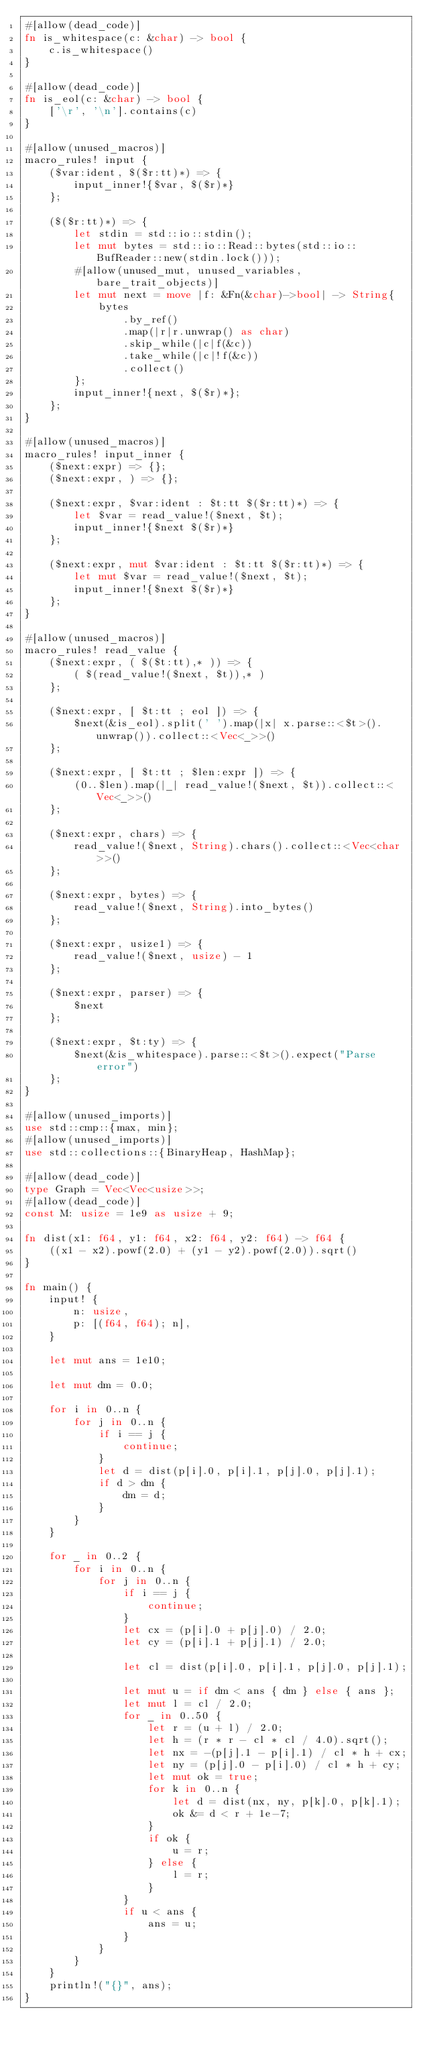Convert code to text. <code><loc_0><loc_0><loc_500><loc_500><_Rust_>#[allow(dead_code)]
fn is_whitespace(c: &char) -> bool {
    c.is_whitespace()
}

#[allow(dead_code)]
fn is_eol(c: &char) -> bool {
    ['\r', '\n'].contains(c)
}

#[allow(unused_macros)]
macro_rules! input {
    ($var:ident, $($r:tt)*) => {
        input_inner!{$var, $($r)*}
    };

    ($($r:tt)*) => {
        let stdin = std::io::stdin();
        let mut bytes = std::io::Read::bytes(std::io::BufReader::new(stdin.lock()));
        #[allow(unused_mut, unused_variables, bare_trait_objects)]
        let mut next = move |f: &Fn(&char)->bool| -> String{
            bytes
                .by_ref()
                .map(|r|r.unwrap() as char)
                .skip_while(|c|f(&c))
                .take_while(|c|!f(&c))
                .collect()
        };
        input_inner!{next, $($r)*};
    };
}

#[allow(unused_macros)]
macro_rules! input_inner {
    ($next:expr) => {};
    ($next:expr, ) => {};

    ($next:expr, $var:ident : $t:tt $($r:tt)*) => {
        let $var = read_value!($next, $t);
        input_inner!{$next $($r)*}
    };

    ($next:expr, mut $var:ident : $t:tt $($r:tt)*) => {
        let mut $var = read_value!($next, $t);
        input_inner!{$next $($r)*}
    };
}

#[allow(unused_macros)]
macro_rules! read_value {
    ($next:expr, ( $($t:tt),* )) => {
        ( $(read_value!($next, $t)),* )
    };

    ($next:expr, [ $t:tt ; eol ]) => {
        $next(&is_eol).split(' ').map(|x| x.parse::<$t>().unwrap()).collect::<Vec<_>>()
    };

    ($next:expr, [ $t:tt ; $len:expr ]) => {
        (0..$len).map(|_| read_value!($next, $t)).collect::<Vec<_>>()
    };

    ($next:expr, chars) => {
        read_value!($next, String).chars().collect::<Vec<char>>()
    };

    ($next:expr, bytes) => {
        read_value!($next, String).into_bytes()
    };

    ($next:expr, usize1) => {
        read_value!($next, usize) - 1
    };

    ($next:expr, parser) => {
        $next
    };

    ($next:expr, $t:ty) => {
        $next(&is_whitespace).parse::<$t>().expect("Parse error")
    };
}

#[allow(unused_imports)]
use std::cmp::{max, min};
#[allow(unused_imports)]
use std::collections::{BinaryHeap, HashMap};

#[allow(dead_code)]
type Graph = Vec<Vec<usize>>;
#[allow(dead_code)]
const M: usize = 1e9 as usize + 9;

fn dist(x1: f64, y1: f64, x2: f64, y2: f64) -> f64 {
    ((x1 - x2).powf(2.0) + (y1 - y2).powf(2.0)).sqrt()
}

fn main() {
    input! {
        n: usize,
        p: [(f64, f64); n],
    }

    let mut ans = 1e10;

    let mut dm = 0.0;

    for i in 0..n {
        for j in 0..n {
            if i == j {
                continue;
            }
            let d = dist(p[i].0, p[i].1, p[j].0, p[j].1);
            if d > dm {
                dm = d;
            }
        }
    }

    for _ in 0..2 {
        for i in 0..n {
            for j in 0..n {
                if i == j {
                    continue;
                }
                let cx = (p[i].0 + p[j].0) / 2.0;
                let cy = (p[i].1 + p[j].1) / 2.0;

                let cl = dist(p[i].0, p[i].1, p[j].0, p[j].1);

                let mut u = if dm < ans { dm } else { ans };
                let mut l = cl / 2.0;
                for _ in 0..50 {
                    let r = (u + l) / 2.0;
                    let h = (r * r - cl * cl / 4.0).sqrt();
                    let nx = -(p[j].1 - p[i].1) / cl * h + cx;
                    let ny = (p[j].0 - p[i].0) / cl * h + cy;
                    let mut ok = true;
                    for k in 0..n {
                        let d = dist(nx, ny, p[k].0, p[k].1);
                        ok &= d < r + 1e-7;
                    }
                    if ok {
                        u = r;
                    } else {
                        l = r;
                    }
                }
                if u < ans {
                    ans = u;
                }
            }
        }
    }
    println!("{}", ans);
}
</code> 